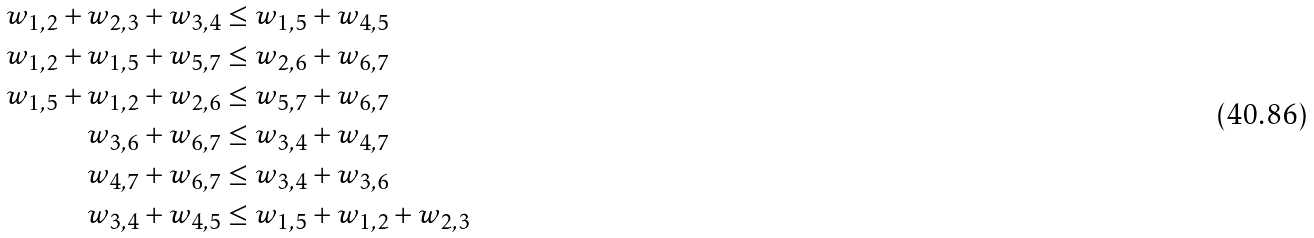Convert formula to latex. <formula><loc_0><loc_0><loc_500><loc_500>w _ { 1 , 2 } + w _ { 2 , 3 } + w _ { 3 , 4 } & \leq w _ { 1 , 5 } + w _ { 4 , 5 } \\ w _ { 1 , 2 } + w _ { 1 , 5 } + w _ { 5 , 7 } & \leq w _ { 2 , 6 } + w _ { 6 , 7 } \\ w _ { 1 , 5 } + w _ { 1 , 2 } + w _ { 2 , 6 } & \leq w _ { 5 , 7 } + w _ { 6 , 7 } \\ w _ { 3 , 6 } + w _ { 6 , 7 } & \leq w _ { 3 , 4 } + w _ { 4 , 7 } \\ w _ { 4 , 7 } + w _ { 6 , 7 } & \leq w _ { 3 , 4 } + w _ { 3 , 6 } \\ w _ { 3 , 4 } + w _ { 4 , 5 } & \leq w _ { 1 , 5 } + w _ { 1 , 2 } + w _ { 2 , 3 }</formula> 